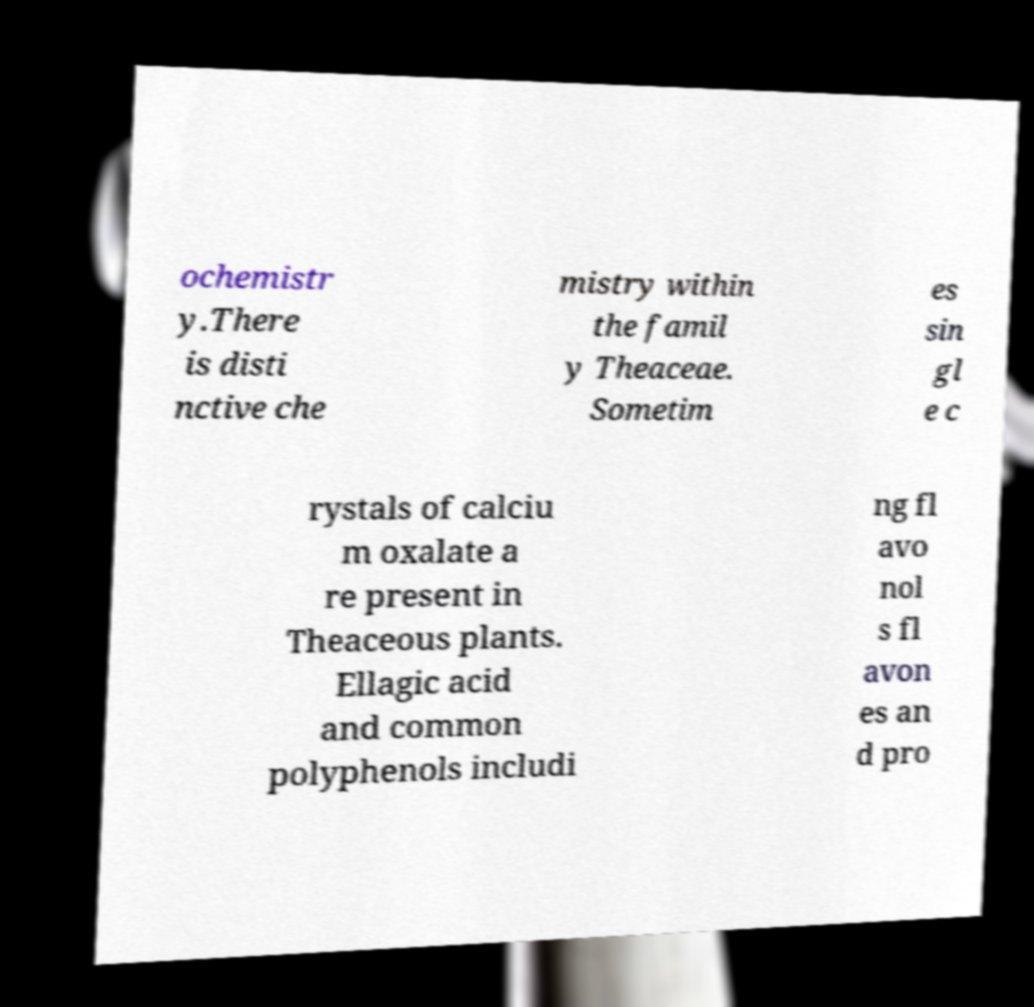Please read and relay the text visible in this image. What does it say? ochemistr y.There is disti nctive che mistry within the famil y Theaceae. Sometim es sin gl e c rystals of calciu m oxalate a re present in Theaceous plants. Ellagic acid and common polyphenols includi ng fl avo nol s fl avon es an d pro 